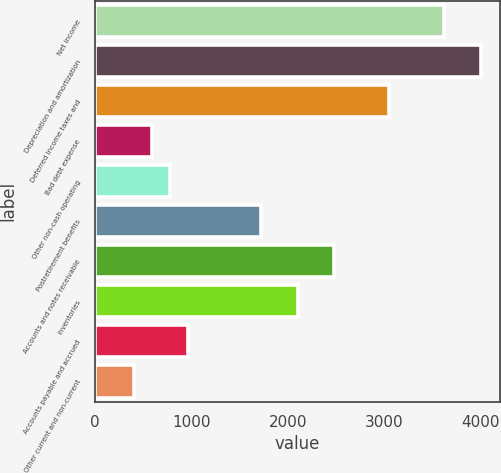Convert chart. <chart><loc_0><loc_0><loc_500><loc_500><bar_chart><fcel>Net income<fcel>Depreciation and amortization<fcel>Deferred income taxes and<fcel>Bad debt expense<fcel>Other non-cash operating<fcel>Postretirement benefits<fcel>Accounts and notes receivable<fcel>Inventories<fcel>Accounts payable and accrued<fcel>Other current and non-current<nl><fcel>3618.7<fcel>3997.3<fcel>3050.8<fcel>589.9<fcel>779.2<fcel>1725.7<fcel>2482.9<fcel>2104.3<fcel>968.5<fcel>400.6<nl></chart> 